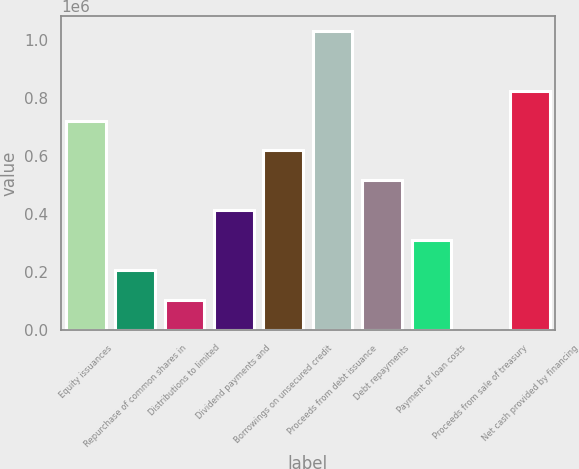Convert chart. <chart><loc_0><loc_0><loc_500><loc_500><bar_chart><fcel>Equity issuances<fcel>Repurchase of common shares in<fcel>Distributions to limited<fcel>Dividend payments and<fcel>Borrowings on unsecured credit<fcel>Proceeds from debt issuance<fcel>Debt repayments<fcel>Payment of loan costs<fcel>Proceeds from sale of treasury<fcel>Net cash provided by financing<nl><fcel>721765<fcel>206810<fcel>103819<fcel>412792<fcel>618774<fcel>1.03074e+06<fcel>515783<fcel>309801<fcel>828<fcel>824756<nl></chart> 